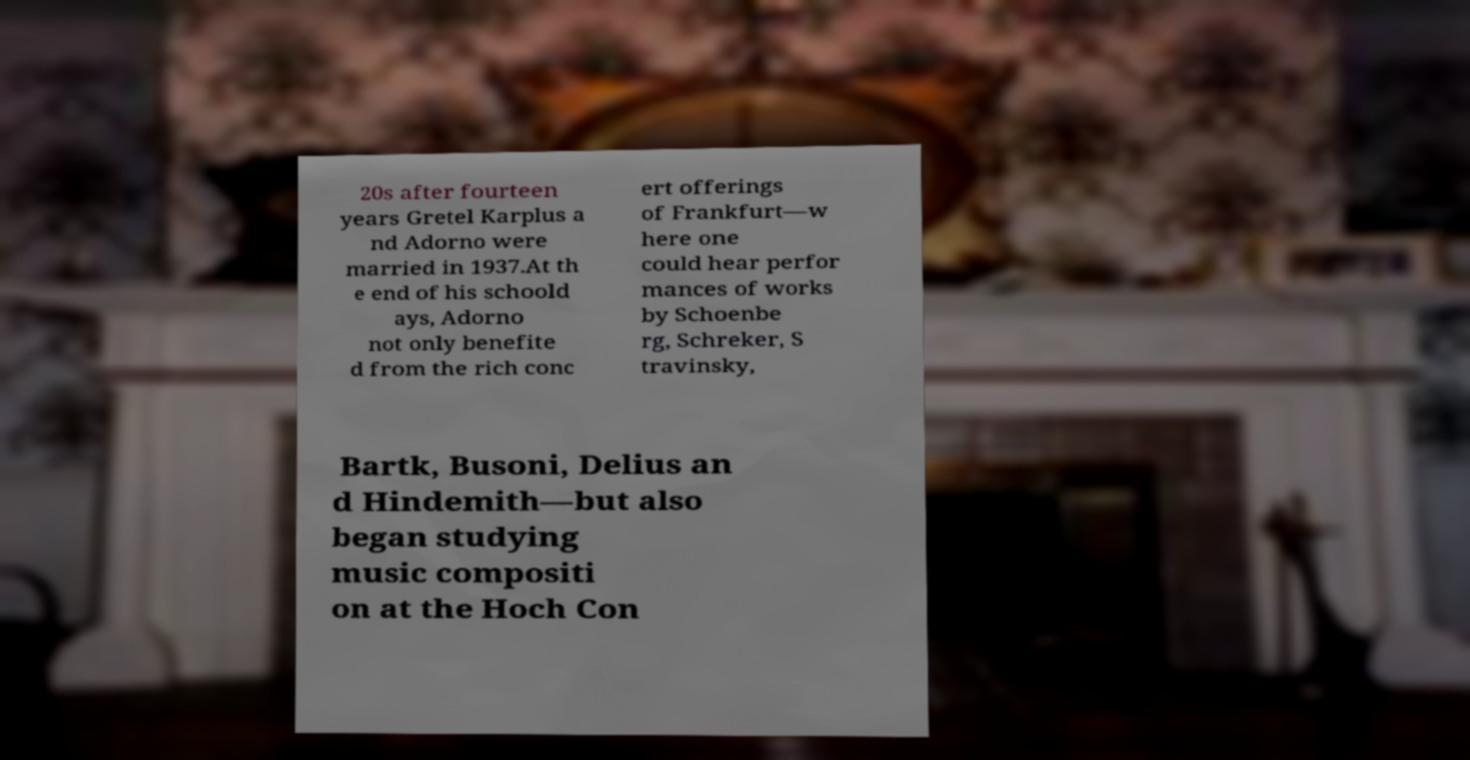I need the written content from this picture converted into text. Can you do that? 20s after fourteen years Gretel Karplus a nd Adorno were married in 1937.At th e end of his schoold ays, Adorno not only benefite d from the rich conc ert offerings of Frankfurt—w here one could hear perfor mances of works by Schoenbe rg, Schreker, S travinsky, Bartk, Busoni, Delius an d Hindemith—but also began studying music compositi on at the Hoch Con 